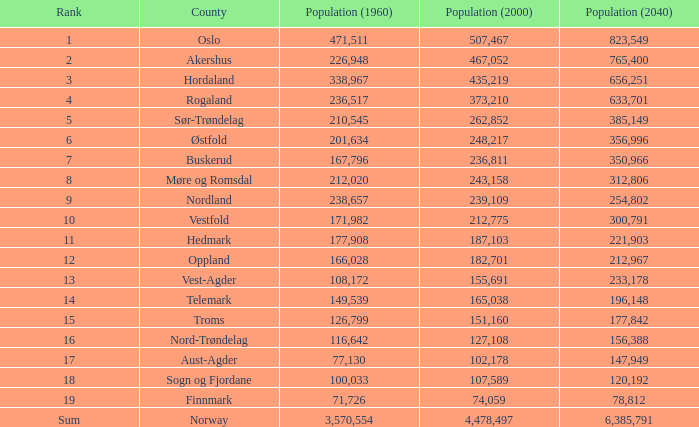With a 2000 population of 507,467, what was the amount of people living in oslo in 1960? None. 